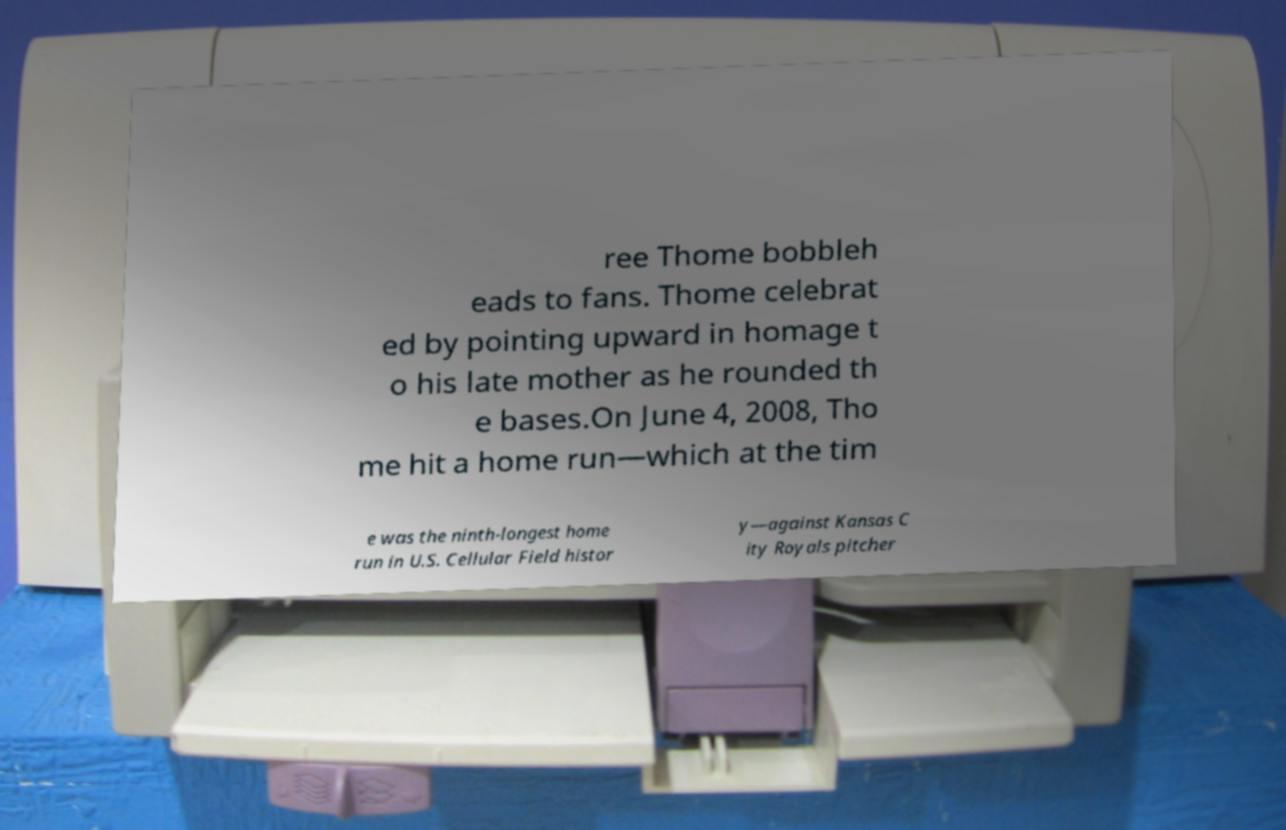What messages or text are displayed in this image? I need them in a readable, typed format. ree Thome bobbleh eads to fans. Thome celebrat ed by pointing upward in homage t o his late mother as he rounded th e bases.On June 4, 2008, Tho me hit a home run—which at the tim e was the ninth-longest home run in U.S. Cellular Field histor y—against Kansas C ity Royals pitcher 